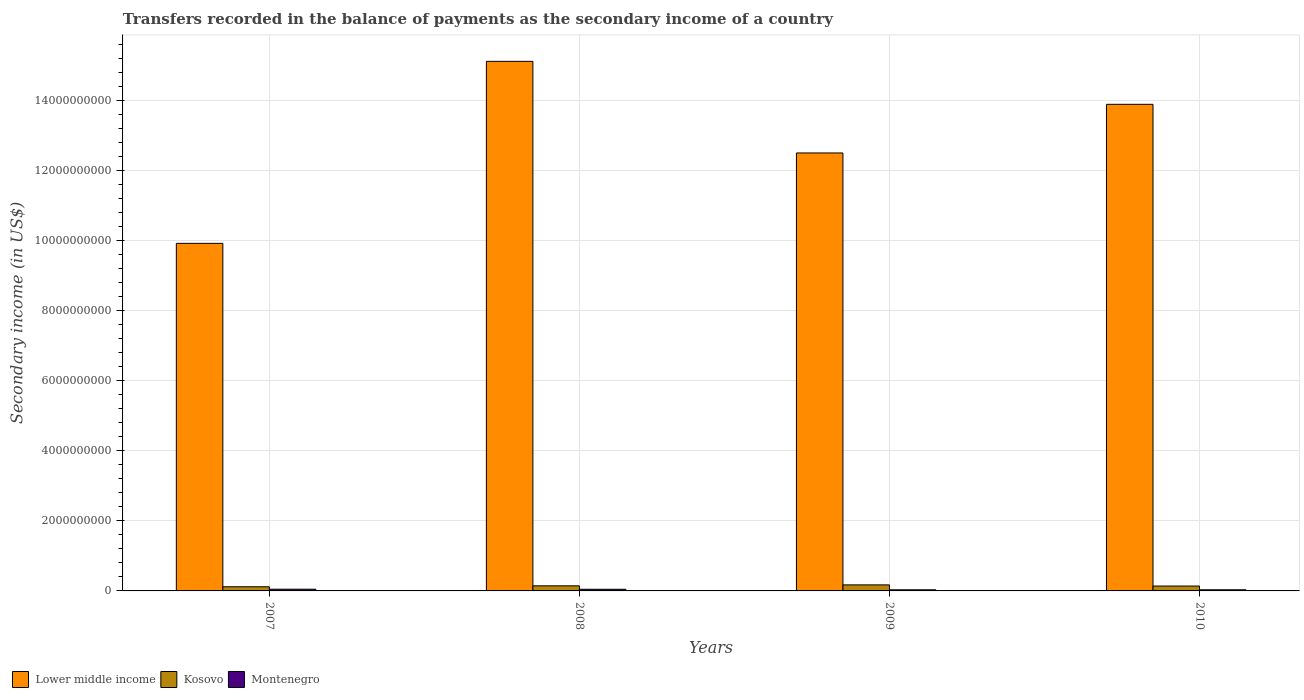How many different coloured bars are there?
Provide a short and direct response. 3. How many groups of bars are there?
Offer a terse response. 4. Are the number of bars on each tick of the X-axis equal?
Your answer should be compact. Yes. How many bars are there on the 1st tick from the left?
Offer a terse response. 3. What is the label of the 2nd group of bars from the left?
Provide a succinct answer. 2008. What is the secondary income of in Lower middle income in 2009?
Ensure brevity in your answer.  1.25e+1. Across all years, what is the maximum secondary income of in Kosovo?
Your answer should be compact. 1.72e+08. Across all years, what is the minimum secondary income of in Lower middle income?
Offer a very short reply. 9.92e+09. In which year was the secondary income of in Montenegro minimum?
Your answer should be very brief. 2009. What is the total secondary income of in Kosovo in the graph?
Your answer should be very brief. 5.76e+08. What is the difference between the secondary income of in Kosovo in 2007 and that in 2008?
Offer a terse response. -2.63e+07. What is the difference between the secondary income of in Kosovo in 2010 and the secondary income of in Montenegro in 2009?
Give a very brief answer. 1.07e+08. What is the average secondary income of in Montenegro per year?
Your response must be concise. 4.01e+07. In the year 2009, what is the difference between the secondary income of in Kosovo and secondary income of in Montenegro?
Keep it short and to the point. 1.40e+08. In how many years, is the secondary income of in Kosovo greater than 4000000000 US$?
Your answer should be compact. 0. What is the ratio of the secondary income of in Montenegro in 2007 to that in 2008?
Your answer should be very brief. 1.03. What is the difference between the highest and the second highest secondary income of in Kosovo?
Your answer should be very brief. 2.72e+07. What is the difference between the highest and the lowest secondary income of in Lower middle income?
Provide a short and direct response. 5.19e+09. What does the 3rd bar from the left in 2010 represents?
Offer a terse response. Montenegro. What does the 2nd bar from the right in 2007 represents?
Keep it short and to the point. Kosovo. Is it the case that in every year, the sum of the secondary income of in Montenegro and secondary income of in Kosovo is greater than the secondary income of in Lower middle income?
Your response must be concise. No. How many bars are there?
Offer a terse response. 12. How many years are there in the graph?
Keep it short and to the point. 4. Are the values on the major ticks of Y-axis written in scientific E-notation?
Your response must be concise. No. Does the graph contain any zero values?
Give a very brief answer. No. Does the graph contain grids?
Provide a short and direct response. Yes. What is the title of the graph?
Your answer should be very brief. Transfers recorded in the balance of payments as the secondary income of a country. Does "Libya" appear as one of the legend labels in the graph?
Keep it short and to the point. No. What is the label or title of the X-axis?
Your answer should be compact. Years. What is the label or title of the Y-axis?
Give a very brief answer. Secondary income (in US$). What is the Secondary income (in US$) in Lower middle income in 2007?
Keep it short and to the point. 9.92e+09. What is the Secondary income (in US$) in Kosovo in 2007?
Your answer should be very brief. 1.19e+08. What is the Secondary income (in US$) of Montenegro in 2007?
Make the answer very short. 4.88e+07. What is the Secondary income (in US$) of Lower middle income in 2008?
Offer a very short reply. 1.51e+1. What is the Secondary income (in US$) of Kosovo in 2008?
Offer a terse response. 1.45e+08. What is the Secondary income (in US$) of Montenegro in 2008?
Give a very brief answer. 4.72e+07. What is the Secondary income (in US$) of Lower middle income in 2009?
Provide a succinct answer. 1.25e+1. What is the Secondary income (in US$) in Kosovo in 2009?
Offer a very short reply. 1.72e+08. What is the Secondary income (in US$) of Montenegro in 2009?
Keep it short and to the point. 3.19e+07. What is the Secondary income (in US$) in Lower middle income in 2010?
Make the answer very short. 1.39e+1. What is the Secondary income (in US$) in Kosovo in 2010?
Your response must be concise. 1.39e+08. What is the Secondary income (in US$) in Montenegro in 2010?
Make the answer very short. 3.24e+07. Across all years, what is the maximum Secondary income (in US$) of Lower middle income?
Your answer should be very brief. 1.51e+1. Across all years, what is the maximum Secondary income (in US$) of Kosovo?
Provide a succinct answer. 1.72e+08. Across all years, what is the maximum Secondary income (in US$) in Montenegro?
Your answer should be very brief. 4.88e+07. Across all years, what is the minimum Secondary income (in US$) in Lower middle income?
Offer a terse response. 9.92e+09. Across all years, what is the minimum Secondary income (in US$) of Kosovo?
Your answer should be very brief. 1.19e+08. Across all years, what is the minimum Secondary income (in US$) in Montenegro?
Keep it short and to the point. 3.19e+07. What is the total Secondary income (in US$) of Lower middle income in the graph?
Give a very brief answer. 5.14e+1. What is the total Secondary income (in US$) of Kosovo in the graph?
Offer a terse response. 5.76e+08. What is the total Secondary income (in US$) in Montenegro in the graph?
Your answer should be very brief. 1.60e+08. What is the difference between the Secondary income (in US$) of Lower middle income in 2007 and that in 2008?
Ensure brevity in your answer.  -5.19e+09. What is the difference between the Secondary income (in US$) of Kosovo in 2007 and that in 2008?
Your answer should be compact. -2.63e+07. What is the difference between the Secondary income (in US$) in Montenegro in 2007 and that in 2008?
Offer a terse response. 1.56e+06. What is the difference between the Secondary income (in US$) of Lower middle income in 2007 and that in 2009?
Offer a very short reply. -2.58e+09. What is the difference between the Secondary income (in US$) in Kosovo in 2007 and that in 2009?
Provide a succinct answer. -5.35e+07. What is the difference between the Secondary income (in US$) in Montenegro in 2007 and that in 2009?
Offer a very short reply. 1.68e+07. What is the difference between the Secondary income (in US$) of Lower middle income in 2007 and that in 2010?
Your response must be concise. -3.97e+09. What is the difference between the Secondary income (in US$) of Kosovo in 2007 and that in 2010?
Provide a succinct answer. -2.05e+07. What is the difference between the Secondary income (in US$) of Montenegro in 2007 and that in 2010?
Your answer should be very brief. 1.64e+07. What is the difference between the Secondary income (in US$) in Lower middle income in 2008 and that in 2009?
Provide a short and direct response. 2.61e+09. What is the difference between the Secondary income (in US$) of Kosovo in 2008 and that in 2009?
Your response must be concise. -2.72e+07. What is the difference between the Secondary income (in US$) in Montenegro in 2008 and that in 2009?
Your answer should be very brief. 1.53e+07. What is the difference between the Secondary income (in US$) in Lower middle income in 2008 and that in 2010?
Provide a short and direct response. 1.23e+09. What is the difference between the Secondary income (in US$) of Kosovo in 2008 and that in 2010?
Your answer should be compact. 5.83e+06. What is the difference between the Secondary income (in US$) of Montenegro in 2008 and that in 2010?
Offer a terse response. 1.48e+07. What is the difference between the Secondary income (in US$) in Lower middle income in 2009 and that in 2010?
Your response must be concise. -1.39e+09. What is the difference between the Secondary income (in US$) of Kosovo in 2009 and that in 2010?
Your answer should be compact. 3.30e+07. What is the difference between the Secondary income (in US$) in Montenegro in 2009 and that in 2010?
Provide a succinct answer. -4.32e+05. What is the difference between the Secondary income (in US$) of Lower middle income in 2007 and the Secondary income (in US$) of Kosovo in 2008?
Keep it short and to the point. 9.77e+09. What is the difference between the Secondary income (in US$) of Lower middle income in 2007 and the Secondary income (in US$) of Montenegro in 2008?
Your answer should be compact. 9.87e+09. What is the difference between the Secondary income (in US$) of Kosovo in 2007 and the Secondary income (in US$) of Montenegro in 2008?
Offer a terse response. 7.16e+07. What is the difference between the Secondary income (in US$) in Lower middle income in 2007 and the Secondary income (in US$) in Kosovo in 2009?
Provide a short and direct response. 9.75e+09. What is the difference between the Secondary income (in US$) in Lower middle income in 2007 and the Secondary income (in US$) in Montenegro in 2009?
Ensure brevity in your answer.  9.89e+09. What is the difference between the Secondary income (in US$) of Kosovo in 2007 and the Secondary income (in US$) of Montenegro in 2009?
Ensure brevity in your answer.  8.69e+07. What is the difference between the Secondary income (in US$) in Lower middle income in 2007 and the Secondary income (in US$) in Kosovo in 2010?
Provide a succinct answer. 9.78e+09. What is the difference between the Secondary income (in US$) of Lower middle income in 2007 and the Secondary income (in US$) of Montenegro in 2010?
Provide a succinct answer. 9.89e+09. What is the difference between the Secondary income (in US$) of Kosovo in 2007 and the Secondary income (in US$) of Montenegro in 2010?
Your response must be concise. 8.65e+07. What is the difference between the Secondary income (in US$) in Lower middle income in 2008 and the Secondary income (in US$) in Kosovo in 2009?
Your answer should be compact. 1.49e+1. What is the difference between the Secondary income (in US$) in Lower middle income in 2008 and the Secondary income (in US$) in Montenegro in 2009?
Provide a short and direct response. 1.51e+1. What is the difference between the Secondary income (in US$) of Kosovo in 2008 and the Secondary income (in US$) of Montenegro in 2009?
Provide a short and direct response. 1.13e+08. What is the difference between the Secondary income (in US$) of Lower middle income in 2008 and the Secondary income (in US$) of Kosovo in 2010?
Make the answer very short. 1.50e+1. What is the difference between the Secondary income (in US$) in Lower middle income in 2008 and the Secondary income (in US$) in Montenegro in 2010?
Offer a terse response. 1.51e+1. What is the difference between the Secondary income (in US$) in Kosovo in 2008 and the Secondary income (in US$) in Montenegro in 2010?
Your response must be concise. 1.13e+08. What is the difference between the Secondary income (in US$) of Lower middle income in 2009 and the Secondary income (in US$) of Kosovo in 2010?
Your answer should be very brief. 1.24e+1. What is the difference between the Secondary income (in US$) in Lower middle income in 2009 and the Secondary income (in US$) in Montenegro in 2010?
Offer a very short reply. 1.25e+1. What is the difference between the Secondary income (in US$) of Kosovo in 2009 and the Secondary income (in US$) of Montenegro in 2010?
Your answer should be very brief. 1.40e+08. What is the average Secondary income (in US$) of Lower middle income per year?
Give a very brief answer. 1.29e+1. What is the average Secondary income (in US$) in Kosovo per year?
Your answer should be very brief. 1.44e+08. What is the average Secondary income (in US$) of Montenegro per year?
Your answer should be very brief. 4.01e+07. In the year 2007, what is the difference between the Secondary income (in US$) in Lower middle income and Secondary income (in US$) in Kosovo?
Your response must be concise. 9.80e+09. In the year 2007, what is the difference between the Secondary income (in US$) of Lower middle income and Secondary income (in US$) of Montenegro?
Provide a succinct answer. 9.87e+09. In the year 2007, what is the difference between the Secondary income (in US$) of Kosovo and Secondary income (in US$) of Montenegro?
Your answer should be very brief. 7.01e+07. In the year 2008, what is the difference between the Secondary income (in US$) of Lower middle income and Secondary income (in US$) of Kosovo?
Keep it short and to the point. 1.50e+1. In the year 2008, what is the difference between the Secondary income (in US$) of Lower middle income and Secondary income (in US$) of Montenegro?
Provide a short and direct response. 1.51e+1. In the year 2008, what is the difference between the Secondary income (in US$) in Kosovo and Secondary income (in US$) in Montenegro?
Your answer should be very brief. 9.79e+07. In the year 2009, what is the difference between the Secondary income (in US$) of Lower middle income and Secondary income (in US$) of Kosovo?
Offer a very short reply. 1.23e+1. In the year 2009, what is the difference between the Secondary income (in US$) of Lower middle income and Secondary income (in US$) of Montenegro?
Provide a succinct answer. 1.25e+1. In the year 2009, what is the difference between the Secondary income (in US$) in Kosovo and Secondary income (in US$) in Montenegro?
Offer a terse response. 1.40e+08. In the year 2010, what is the difference between the Secondary income (in US$) of Lower middle income and Secondary income (in US$) of Kosovo?
Provide a succinct answer. 1.37e+1. In the year 2010, what is the difference between the Secondary income (in US$) in Lower middle income and Secondary income (in US$) in Montenegro?
Provide a succinct answer. 1.39e+1. In the year 2010, what is the difference between the Secondary income (in US$) of Kosovo and Secondary income (in US$) of Montenegro?
Make the answer very short. 1.07e+08. What is the ratio of the Secondary income (in US$) of Lower middle income in 2007 to that in 2008?
Offer a terse response. 0.66. What is the ratio of the Secondary income (in US$) of Kosovo in 2007 to that in 2008?
Ensure brevity in your answer.  0.82. What is the ratio of the Secondary income (in US$) of Montenegro in 2007 to that in 2008?
Give a very brief answer. 1.03. What is the ratio of the Secondary income (in US$) in Lower middle income in 2007 to that in 2009?
Offer a very short reply. 0.79. What is the ratio of the Secondary income (in US$) in Kosovo in 2007 to that in 2009?
Your answer should be compact. 0.69. What is the ratio of the Secondary income (in US$) in Montenegro in 2007 to that in 2009?
Provide a succinct answer. 1.53. What is the ratio of the Secondary income (in US$) of Kosovo in 2007 to that in 2010?
Ensure brevity in your answer.  0.85. What is the ratio of the Secondary income (in US$) of Montenegro in 2007 to that in 2010?
Offer a terse response. 1.51. What is the ratio of the Secondary income (in US$) in Lower middle income in 2008 to that in 2009?
Ensure brevity in your answer.  1.21. What is the ratio of the Secondary income (in US$) in Kosovo in 2008 to that in 2009?
Keep it short and to the point. 0.84. What is the ratio of the Secondary income (in US$) in Montenegro in 2008 to that in 2009?
Your answer should be very brief. 1.48. What is the ratio of the Secondary income (in US$) of Lower middle income in 2008 to that in 2010?
Your response must be concise. 1.09. What is the ratio of the Secondary income (in US$) of Kosovo in 2008 to that in 2010?
Offer a terse response. 1.04. What is the ratio of the Secondary income (in US$) in Montenegro in 2008 to that in 2010?
Your answer should be very brief. 1.46. What is the ratio of the Secondary income (in US$) of Kosovo in 2009 to that in 2010?
Ensure brevity in your answer.  1.24. What is the ratio of the Secondary income (in US$) in Montenegro in 2009 to that in 2010?
Provide a short and direct response. 0.99. What is the difference between the highest and the second highest Secondary income (in US$) in Lower middle income?
Offer a terse response. 1.23e+09. What is the difference between the highest and the second highest Secondary income (in US$) of Kosovo?
Offer a very short reply. 2.72e+07. What is the difference between the highest and the second highest Secondary income (in US$) in Montenegro?
Your response must be concise. 1.56e+06. What is the difference between the highest and the lowest Secondary income (in US$) of Lower middle income?
Ensure brevity in your answer.  5.19e+09. What is the difference between the highest and the lowest Secondary income (in US$) of Kosovo?
Your answer should be very brief. 5.35e+07. What is the difference between the highest and the lowest Secondary income (in US$) of Montenegro?
Your answer should be very brief. 1.68e+07. 